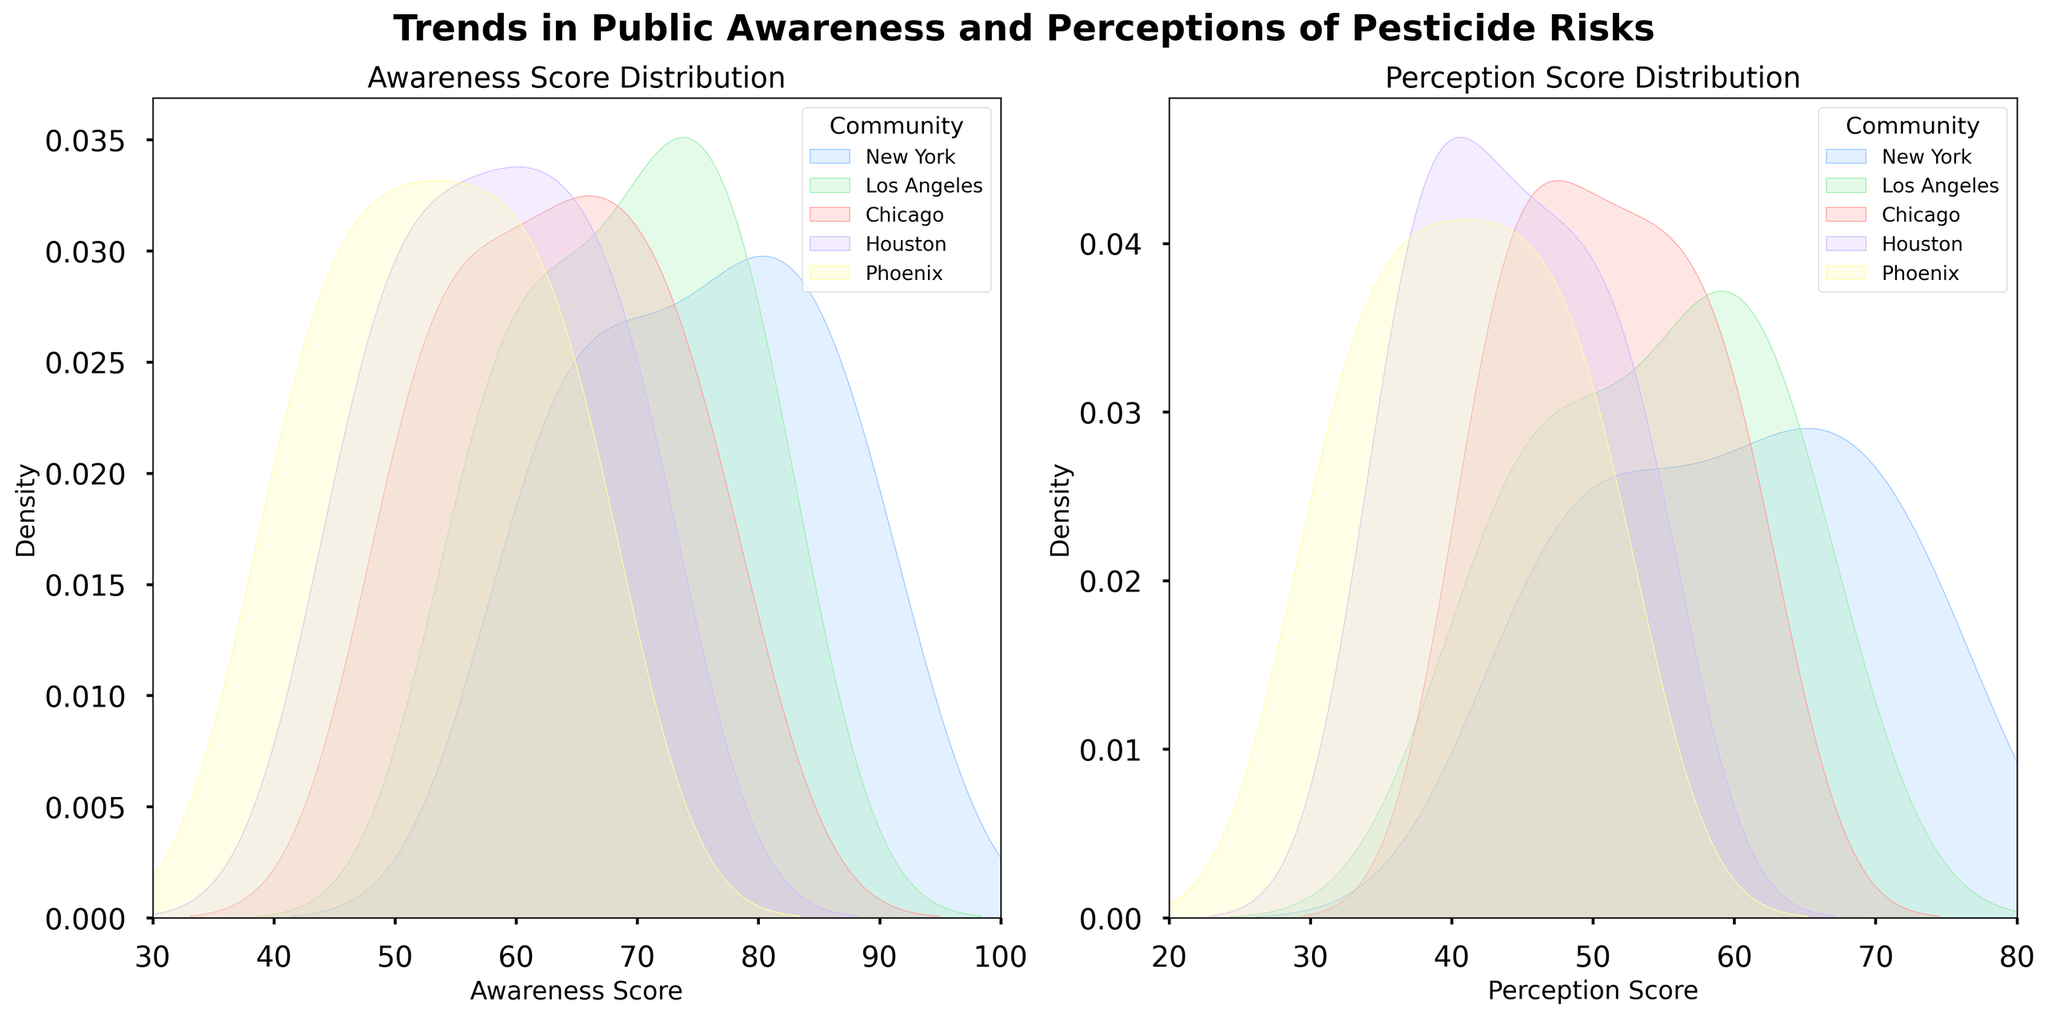what is the title of the plot? The title is located at the top center of the plot. From the visual information provided, it reads "Trends in Public Awareness and Perceptions of Pesticide Risks". The title summarizes the main focus of the plot.
Answer: Trends in Public Awareness and Perceptions of Pesticide Risks What are the x-axis and y-axis labels for the left subplot? The x-axis label indicates the variable being measured along the horizontal axis, and the y-axis label indicates the measurement along the vertical axis. For the left subplot, the x-axis is labeled "Awareness Score" and the y-axis is labeled "Density".
Answer: Awareness Score, Density Which community has the highest density in awareness scores? To determine this, look for the peak of the curve on the awareness score density plot (left subplot). The community with the highest curve peak has the highest density. From the plot, New York has the highest peak.
Answer: New York What's the awareness score range shown in the left subplot? The x-axis range for the awareness score is indicated by its limits. In the left subplot, it ranges from 30 to 100.
Answer: 30 to 100 How do the perception scores compare between Phoenix and Houston in the right subplot? To compare, look at the height and spread of the density curves for each community. Phoenix and Houston both have lighter peaks, but Houston's peak is slightly higher and earlier than Phoenix. Hence, Houston tends to have higher perception scores than Phoenix.
Answer: Houston generally has higher scores than Phoenix Which community shows the fastest increase in awareness score over the years? To determine this, consider the spread and peaks of the density curves for each community. The curve that is most right-shifted indicates the fastest increase. New York shows the fastest increase as its distribution is most rightward.
Answer: New York Is there a similar trend between awareness and perception scores among the communities? By examining the left and right subplots' peaks and shapes for each community, a similar trend would be indicated if curves for a community in both plots shift similarly. Yes, both awareness and perception plots show that New York has the highest density, followed by Los Angeles, Chicago, Houston, and Phoenix, indicating a similar trend.
Answer: Yes What's the difference between the highest awareness and perception scores for New York? Identify the peaks on the New York density curves in both subplots. The highest awareness score for New York is around 90, and the highest perception score is around 75, so the difference is 90 - 75 = 15.
Answer: 15 